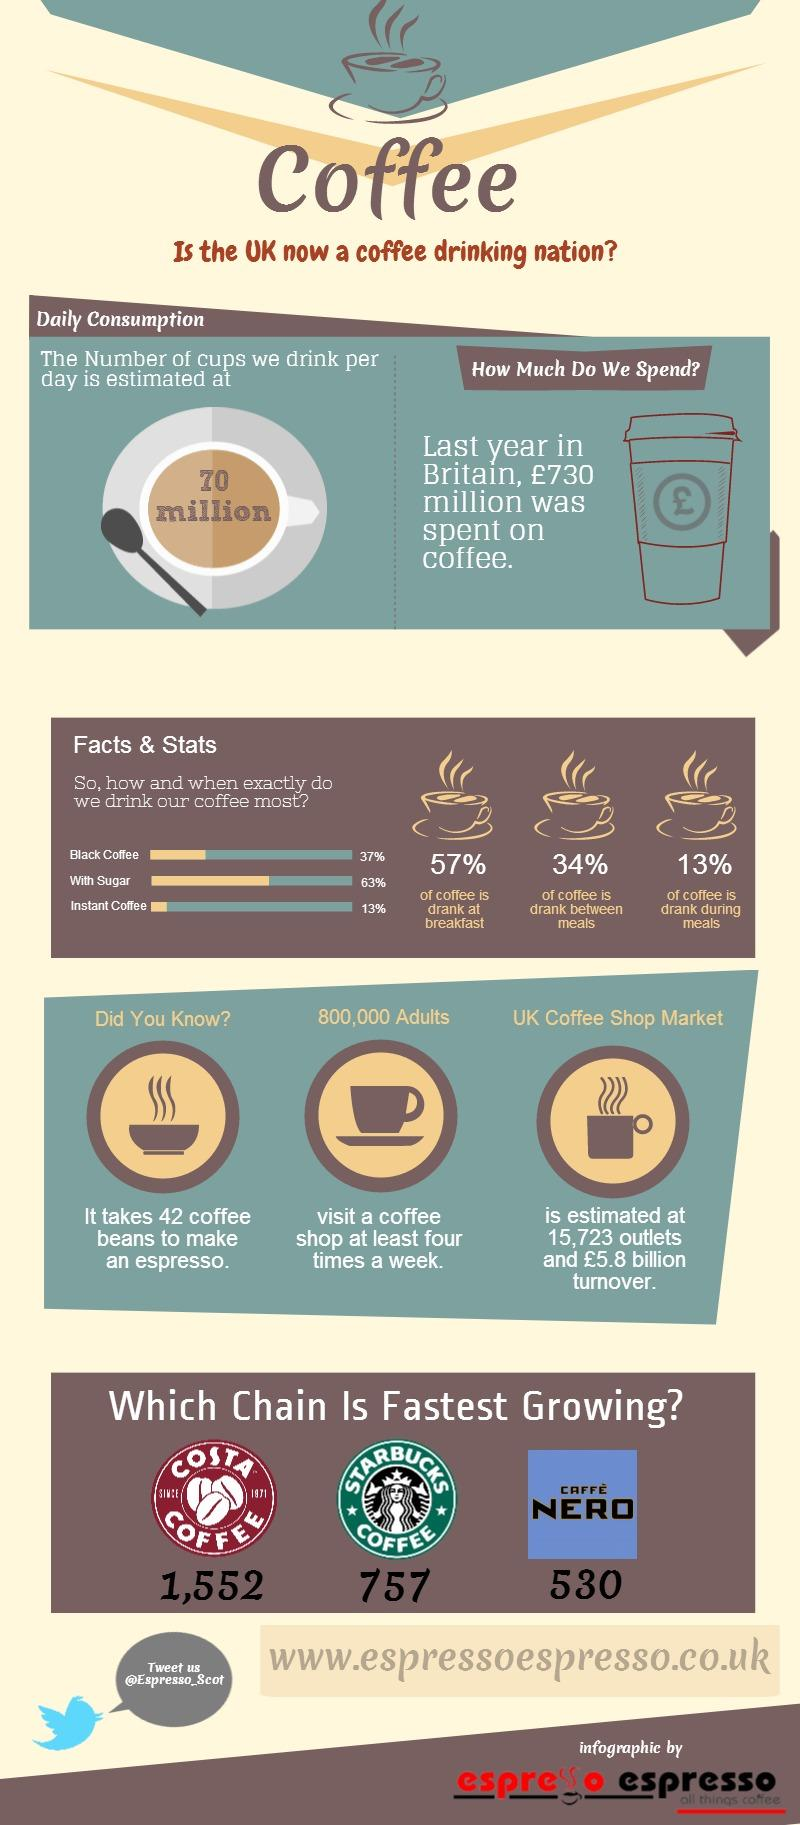List a handful of essential elements in this visual. The overall turnover for the UK coffee shop market is estimated to be approximately £5.8 billion. The chain with the second-fastest growth is Starbucks. The coffee was most likely drunk at breakfast, as that was the time when it was consumed in large quantities. Instant coffee is the most commonly consumed form of coffee due to its ease of preparation and longer shelf life. Coffee is most commonly consumed in its pure, black form. 